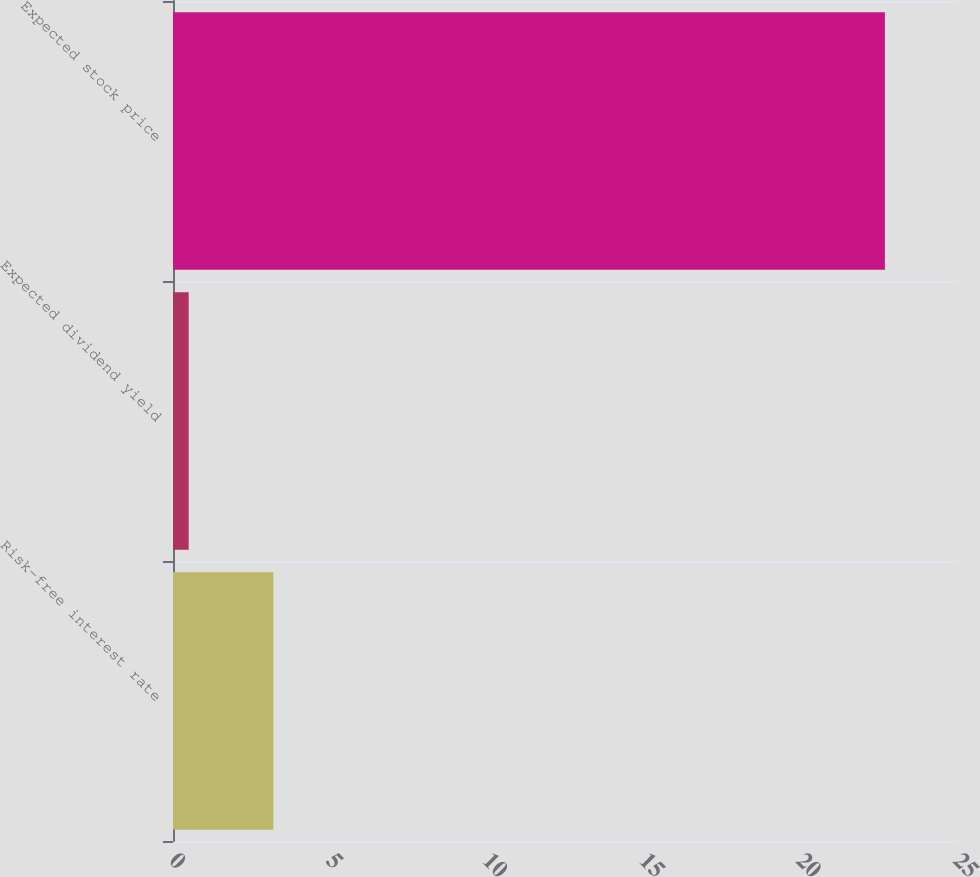Convert chart. <chart><loc_0><loc_0><loc_500><loc_500><bar_chart><fcel>Risk-free interest rate<fcel>Expected dividend yield<fcel>Expected stock price<nl><fcel>3.2<fcel>0.5<fcel>22.7<nl></chart> 